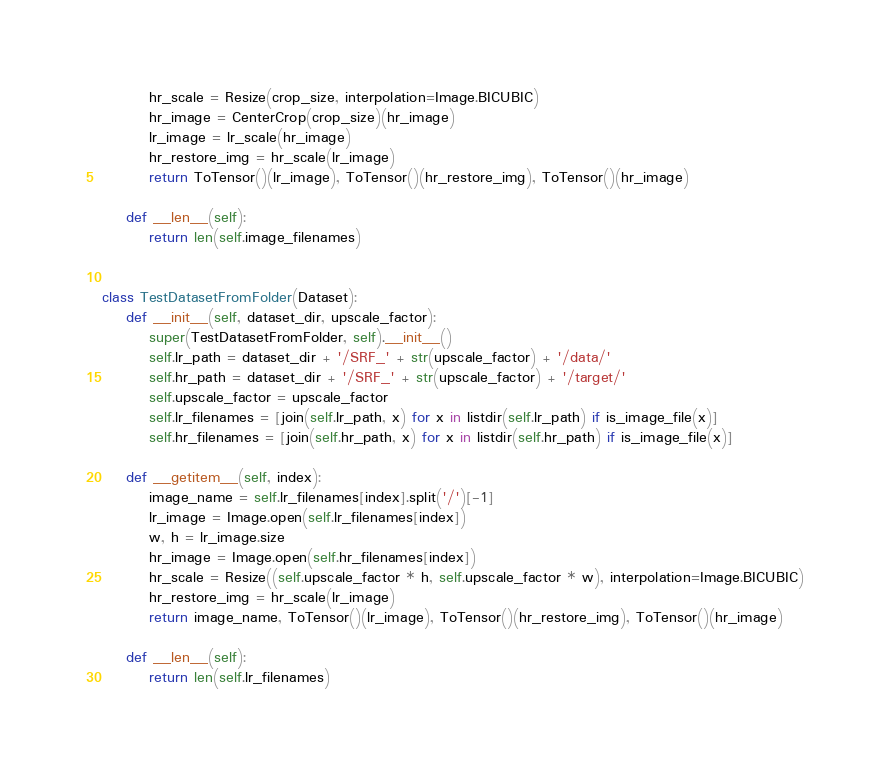Convert code to text. <code><loc_0><loc_0><loc_500><loc_500><_Python_>        hr_scale = Resize(crop_size, interpolation=Image.BICUBIC)
        hr_image = CenterCrop(crop_size)(hr_image)
        lr_image = lr_scale(hr_image)
        hr_restore_img = hr_scale(lr_image)
        return ToTensor()(lr_image), ToTensor()(hr_restore_img), ToTensor()(hr_image)

    def __len__(self):
        return len(self.image_filenames)


class TestDatasetFromFolder(Dataset):
    def __init__(self, dataset_dir, upscale_factor):
        super(TestDatasetFromFolder, self).__init__()
        self.lr_path = dataset_dir + '/SRF_' + str(upscale_factor) + '/data/'
        self.hr_path = dataset_dir + '/SRF_' + str(upscale_factor) + '/target/'
        self.upscale_factor = upscale_factor
        self.lr_filenames = [join(self.lr_path, x) for x in listdir(self.lr_path) if is_image_file(x)]
        self.hr_filenames = [join(self.hr_path, x) for x in listdir(self.hr_path) if is_image_file(x)]

    def __getitem__(self, index):
        image_name = self.lr_filenames[index].split('/')[-1]
        lr_image = Image.open(self.lr_filenames[index])
        w, h = lr_image.size
        hr_image = Image.open(self.hr_filenames[index])
        hr_scale = Resize((self.upscale_factor * h, self.upscale_factor * w), interpolation=Image.BICUBIC)
        hr_restore_img = hr_scale(lr_image)
        return image_name, ToTensor()(lr_image), ToTensor()(hr_restore_img), ToTensor()(hr_image)

    def __len__(self):
        return len(self.lr_filenames)
</code> 